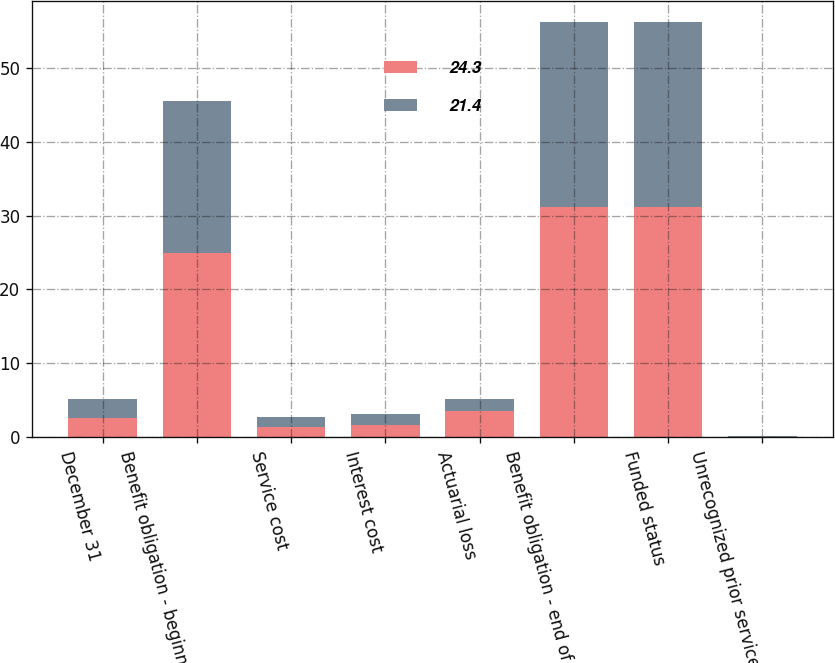<chart> <loc_0><loc_0><loc_500><loc_500><stacked_bar_chart><ecel><fcel>December 31<fcel>Benefit obligation - beginning<fcel>Service cost<fcel>Interest cost<fcel>Actuarial loss<fcel>Benefit obligation - end of<fcel>Funded status<fcel>Unrecognized prior service<nl><fcel>24.3<fcel>2.6<fcel>25<fcel>1.4<fcel>1.7<fcel>3.5<fcel>31.2<fcel>31.2<fcel>0.1<nl><fcel>21.4<fcel>2.6<fcel>20.5<fcel>1.3<fcel>1.5<fcel>1.7<fcel>25<fcel>25<fcel>0.1<nl></chart> 